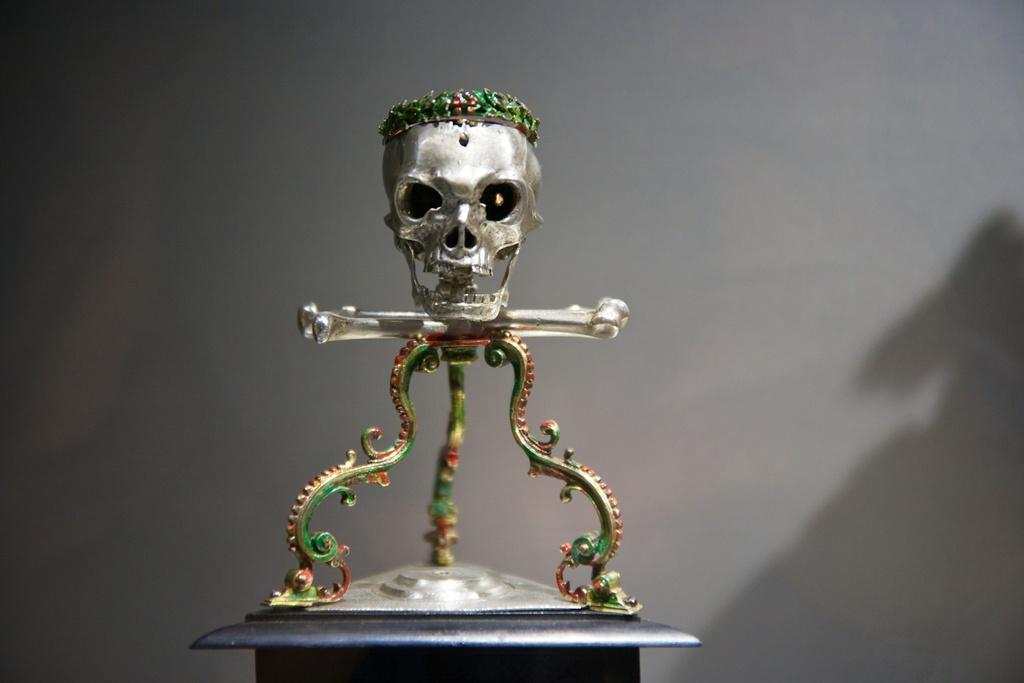What type of material is used to create the skull and bone in the image? The skull and bone in the image are made up of metal. What is the primary object in the image? The primary object in the image is a table. What is placed on the table in the image? There is a metal object on the table in the image. What can be seen in the background of the image? There is a wall in the background of the image. What type of cream is being used to decorate the quilt in the image? There is no quilt or cream present in the image; it features a metal skull, bone, table, and wall. 